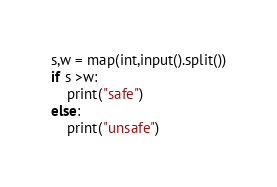<code> <loc_0><loc_0><loc_500><loc_500><_Python_>s,w = map(int,input().split())
if s >w:
    print("safe")
else:
    print("unsafe")</code> 